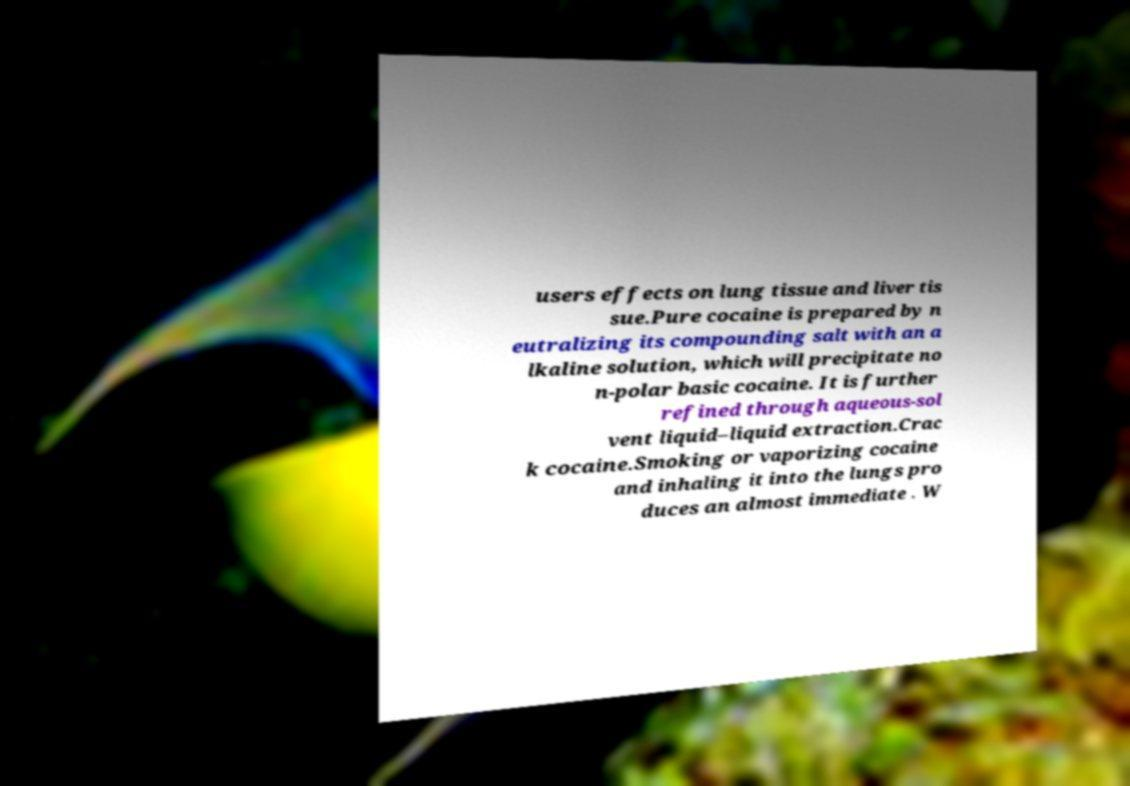Can you read and provide the text displayed in the image?This photo seems to have some interesting text. Can you extract and type it out for me? users effects on lung tissue and liver tis sue.Pure cocaine is prepared by n eutralizing its compounding salt with an a lkaline solution, which will precipitate no n-polar basic cocaine. It is further refined through aqueous-sol vent liquid–liquid extraction.Crac k cocaine.Smoking or vaporizing cocaine and inhaling it into the lungs pro duces an almost immediate . W 